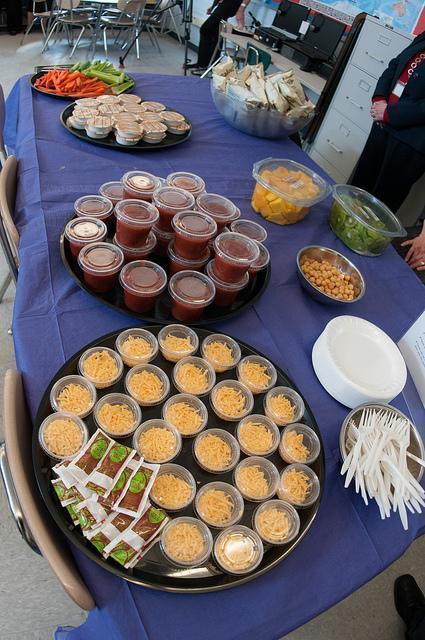What type of building might this be?
Choose the correct response and explain in the format: 'Answer: answer
Rationale: rationale.'
Options: Daycare, school, courthouse, church. Answer: school.
Rationale: There is a whiteboard and desks. 